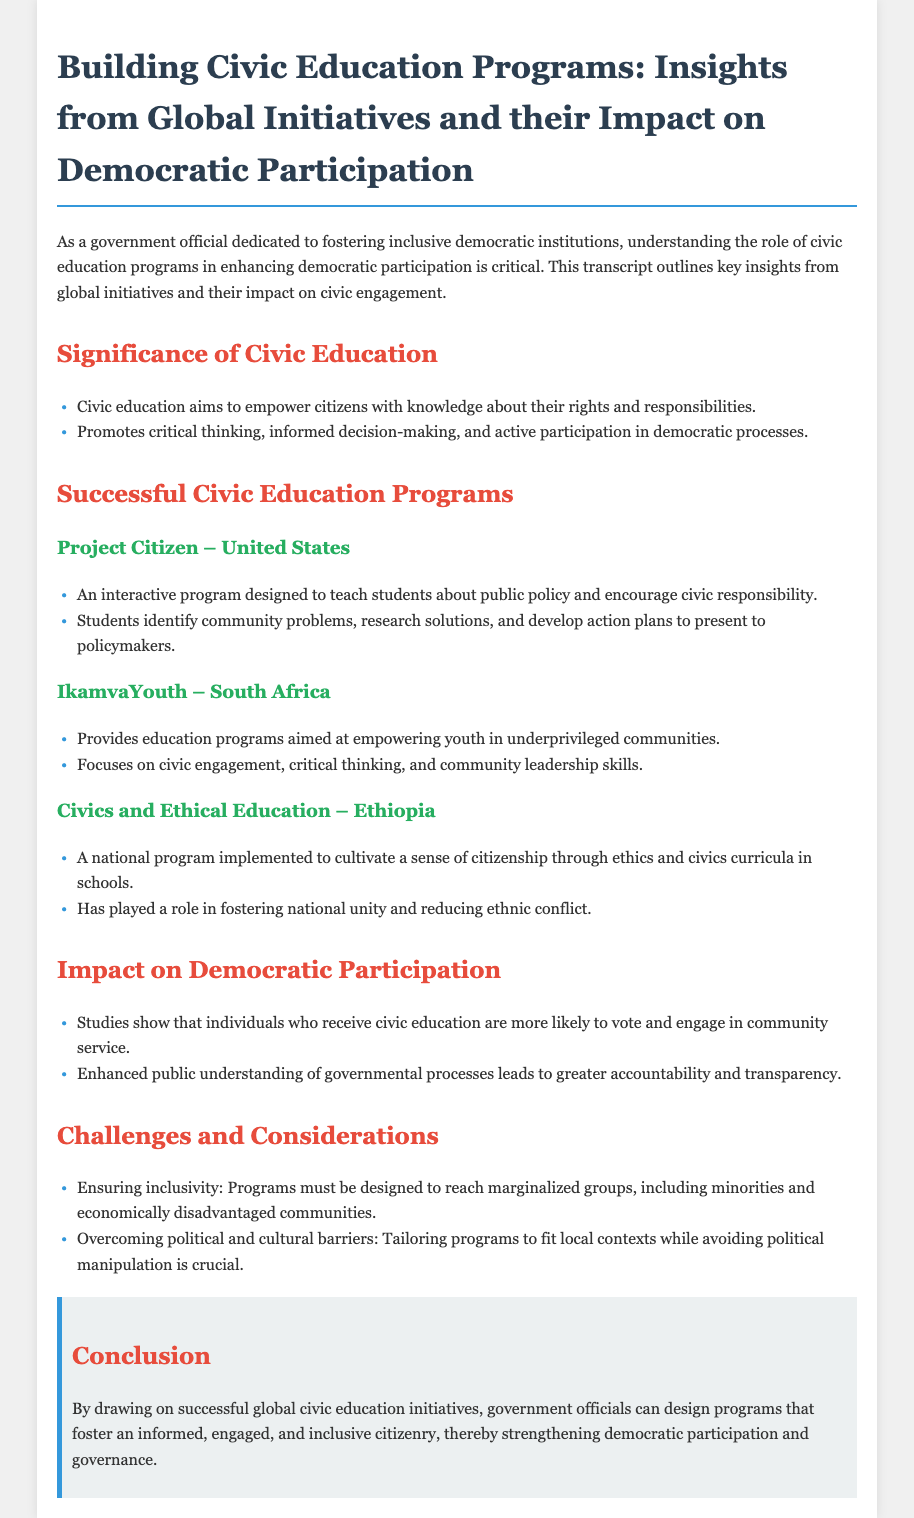What is the main purpose of civic education? Civic education aims to empower citizens with knowledge about their rights and responsibilities, promoting active participation in democratic processes.
Answer: Empowerment What initiative focuses on underprivileged youth in South Africa? The initiative mentioned that provides education programs aimed at empowering youth in underprivileged communities is IkamvaYouth.
Answer: IkamvaYouth Which program has contributed to fostering national unity in Ethiopia? The program implemented in Ethiopia to cultivate a sense of citizenship is Civics and Ethical Education.
Answer: Civics and Ethical Education What is a key benefit of civic education mentioned in the document? A key benefit highlighted is that individuals who receive civic education are more likely to vote and engage in community service.
Answer: More likely to vote What challenge must civic education programs address to ensure inclusivity? Programs must be designed to reach marginalized groups, including minorities and economically disadvantaged communities.
Answer: Inclusivity What critical skill does Project Citizen aim to teach students? Project Citizen is designed to teach students about public policy and encourage civic responsibility.
Answer: Civic responsibility Which country implemented the program called IkamvaYouth? The program IkamvaYouth is implemented in South Africa.
Answer: South Africa What aspect of governmental processes does enhanced public understanding lead to? Enhanced public understanding of governmental processes leads to greater accountability and transparency.
Answer: Accountability and transparency 